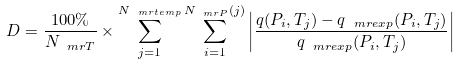<formula> <loc_0><loc_0><loc_500><loc_500>D = \frac { 1 0 0 \% } { N _ { \ m r { T } } } \times \sum _ { j = 1 } ^ { N _ { \ m r { t e m p } } } \sum _ { i = 1 } ^ { N _ { \ m r { P } } ( j ) } \left | \frac { q ( P _ { i } , T _ { j } ) - q _ { \ m r { e x p } } ( P _ { i } , T _ { j } ) } { q _ { \ m r { e x p } } ( P _ { i } , T _ { j } ) } \right |</formula> 